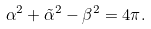<formula> <loc_0><loc_0><loc_500><loc_500>\alpha ^ { 2 } + { \tilde { \alpha } } ^ { 2 } - \beta ^ { 2 } = 4 \pi .</formula> 